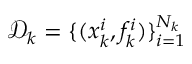Convert formula to latex. <formula><loc_0><loc_0><loc_500><loc_500>\mathcal { D } _ { k } = \{ ( x _ { k } ^ { i } , f _ { k } ^ { i } ) \} _ { i = 1 } ^ { N _ { k } }</formula> 